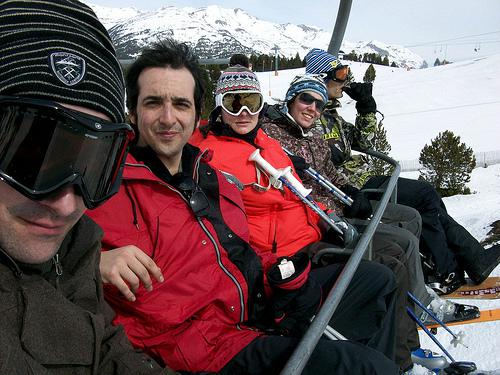Question: what is in the ground?
Choices:
A. Flowers.
B. Hail.
C. Fire.
D. Snow.
Answer with the letter. Answer: D Question: what is the color of the plants?
Choices:
A. Purple.
B. Green.
C. Red.
D. Brown.
Answer with the letter. Answer: B Question: how is the day?
Choices:
A. Rainy.
B. Foggy.
C. Sunny.
D. Snowy.
Answer with the letter. Answer: C Question: where is the picture taken?
Choices:
A. A ski resort.
B. A school.
C. Ski slopes.
D. A home.
Answer with the letter. Answer: C 